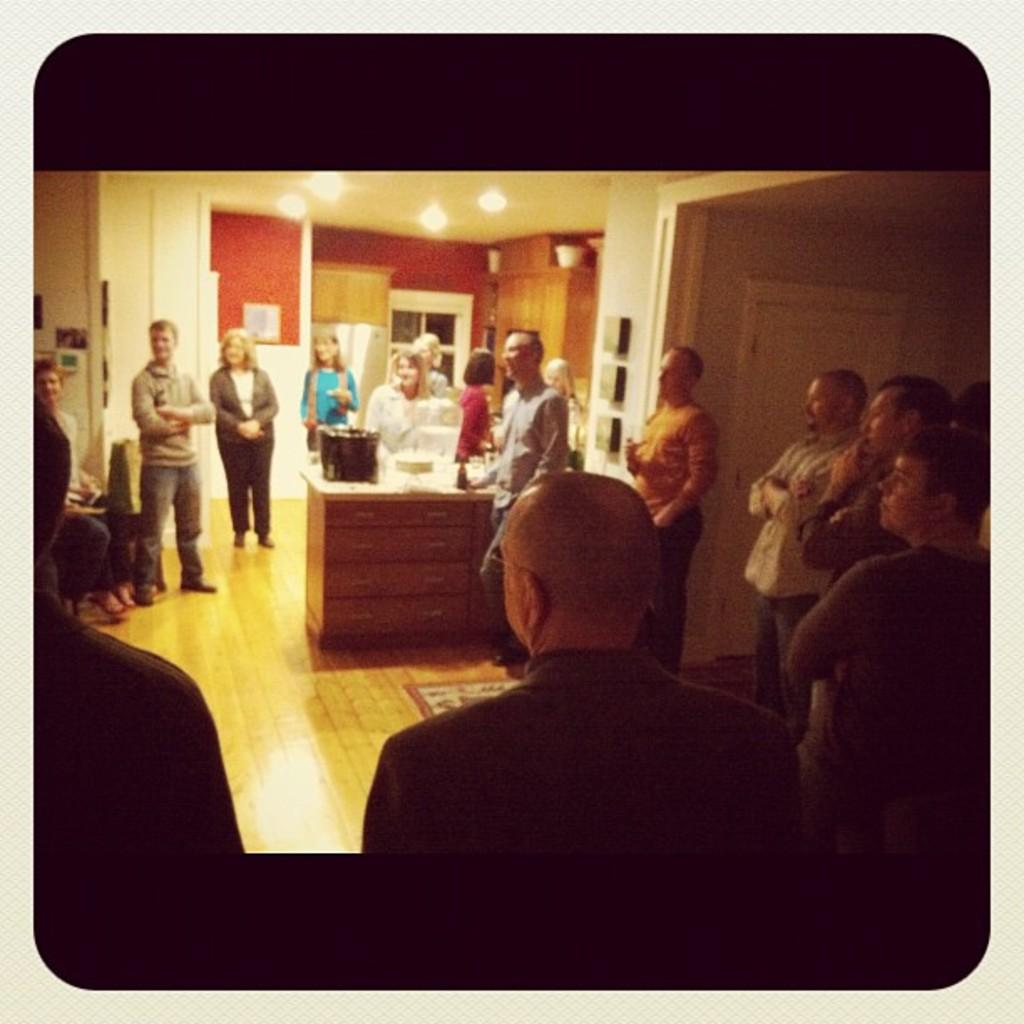What can be seen in the image? There are people standing in the image. What is the background of the image? There is a wall in the image. What type of train can be seen in the image? There is no train present in the image; it only features people standing near a wall. What decision are the people making in the image? The image does not provide any information about the people's decisions or actions. 